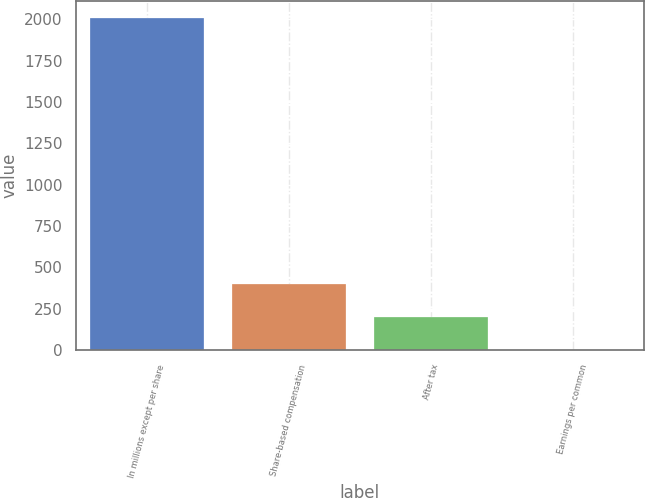Convert chart to OTSL. <chart><loc_0><loc_0><loc_500><loc_500><bar_chart><fcel>In millions except per share<fcel>Share-based compensation<fcel>After tax<fcel>Earnings per common<nl><fcel>2010<fcel>402.05<fcel>201.05<fcel>0.05<nl></chart> 